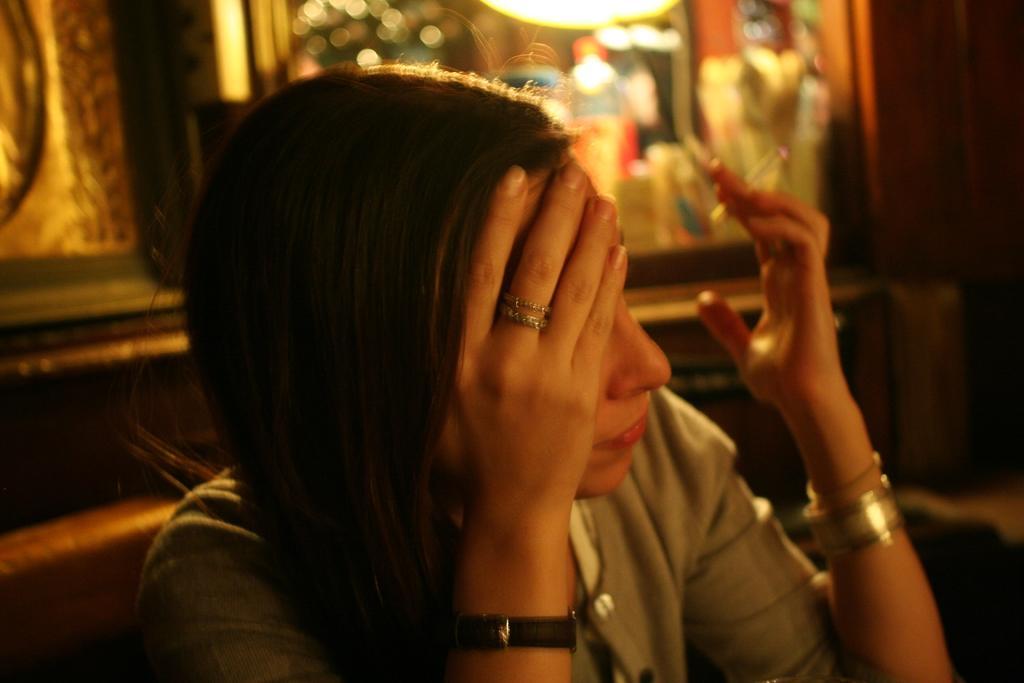In one or two sentences, can you explain what this image depicts? In the image we can see a woman wearing clothes, wristwatch, bracelet and a fingering, in her hand there is a cigarette and the background is blurred. 